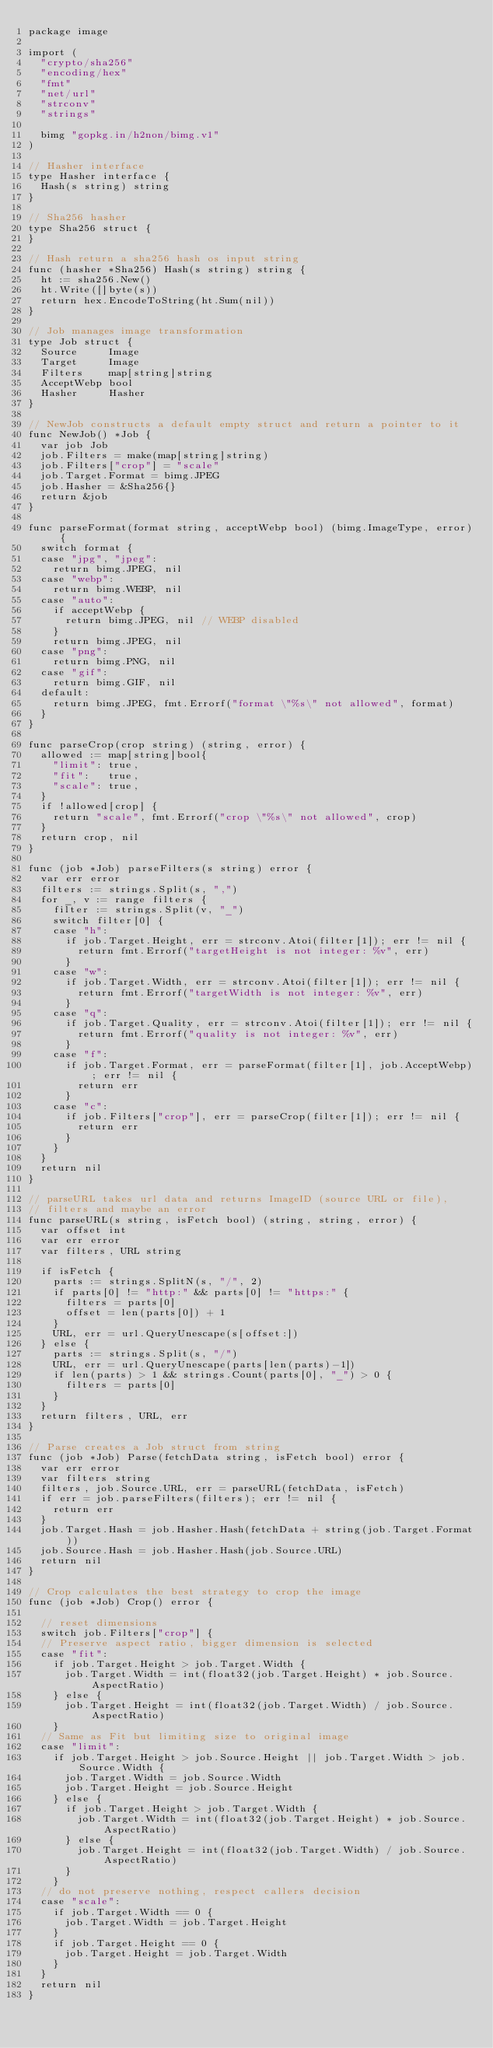<code> <loc_0><loc_0><loc_500><loc_500><_Go_>package image

import (
	"crypto/sha256"
	"encoding/hex"
	"fmt"
	"net/url"
	"strconv"
	"strings"

	bimg "gopkg.in/h2non/bimg.v1"
)

// Hasher interface
type Hasher interface {
	Hash(s string) string
}

// Sha256 hasher
type Sha256 struct {
}

// Hash return a sha256 hash os input string
func (hasher *Sha256) Hash(s string) string {
	ht := sha256.New()
	ht.Write([]byte(s))
	return hex.EncodeToString(ht.Sum(nil))
}

// Job manages image transformation
type Job struct {
	Source     Image
	Target     Image
	Filters    map[string]string
	AcceptWebp bool
	Hasher     Hasher
}

// NewJob constructs a default empty struct and return a pointer to it
func NewJob() *Job {
	var job Job
	job.Filters = make(map[string]string)
	job.Filters["crop"] = "scale"
	job.Target.Format = bimg.JPEG
	job.Hasher = &Sha256{}
	return &job
}

func parseFormat(format string, acceptWebp bool) (bimg.ImageType, error) {
	switch format {
	case "jpg", "jpeg":
		return bimg.JPEG, nil
	case "webp":
		return bimg.WEBP, nil
	case "auto":
		if acceptWebp {
			return bimg.JPEG, nil // WEBP disabled
		}
		return bimg.JPEG, nil
	case "png":
		return bimg.PNG, nil
	case "gif":
		return bimg.GIF, nil
	default:
		return bimg.JPEG, fmt.Errorf("format \"%s\" not allowed", format)
	}
}

func parseCrop(crop string) (string, error) {
	allowed := map[string]bool{
		"limit": true,
		"fit":   true,
		"scale": true,
	}
	if !allowed[crop] {
		return "scale", fmt.Errorf("crop \"%s\" not allowed", crop)
	}
	return crop, nil
}

func (job *Job) parseFilters(s string) error {
	var err error
	filters := strings.Split(s, ",")
	for _, v := range filters {
		filter := strings.Split(v, "_")
		switch filter[0] {
		case "h":
			if job.Target.Height, err = strconv.Atoi(filter[1]); err != nil {
				return fmt.Errorf("targetHeight is not integer: %v", err)
			}
		case "w":
			if job.Target.Width, err = strconv.Atoi(filter[1]); err != nil {
				return fmt.Errorf("targetWidth is not integer: %v", err)
			}
		case "q":
			if job.Target.Quality, err = strconv.Atoi(filter[1]); err != nil {
				return fmt.Errorf("quality is not integer: %v", err)
			}
		case "f":
			if job.Target.Format, err = parseFormat(filter[1], job.AcceptWebp); err != nil {
				return err
			}
		case "c":
			if job.Filters["crop"], err = parseCrop(filter[1]); err != nil {
				return err
			}
		}
	}
	return nil
}

// parseURL takes url data and returns ImageID (source URL or file),
// filters and maybe an error
func parseURL(s string, isFetch bool) (string, string, error) {
	var offset int
	var err error
	var filters, URL string

	if isFetch {
		parts := strings.SplitN(s, "/", 2)
		if parts[0] != "http:" && parts[0] != "https:" {
			filters = parts[0]
			offset = len(parts[0]) + 1
		}
		URL, err = url.QueryUnescape(s[offset:])
	} else {
		parts := strings.Split(s, "/")
		URL, err = url.QueryUnescape(parts[len(parts)-1])
		if len(parts) > 1 && strings.Count(parts[0], "_") > 0 {
			filters = parts[0]
		}
	}
	return filters, URL, err
}

// Parse creates a Job struct from string
func (job *Job) Parse(fetchData string, isFetch bool) error {
	var err error
	var filters string
	filters, job.Source.URL, err = parseURL(fetchData, isFetch)
	if err = job.parseFilters(filters); err != nil {
		return err
	}
	job.Target.Hash = job.Hasher.Hash(fetchData + string(job.Target.Format))
	job.Source.Hash = job.Hasher.Hash(job.Source.URL)
	return nil
}

// Crop calculates the best strategy to crop the image
func (job *Job) Crop() error {

	// reset dimensions
	switch job.Filters["crop"] {
	// Preserve aspect ratio, bigger dimension is selected
	case "fit":
		if job.Target.Height > job.Target.Width {
			job.Target.Width = int(float32(job.Target.Height) * job.Source.AspectRatio)
		} else {
			job.Target.Height = int(float32(job.Target.Width) / job.Source.AspectRatio)
		}
	// Same as Fit but limiting size to original image
	case "limit":
		if job.Target.Height > job.Source.Height || job.Target.Width > job.Source.Width {
			job.Target.Width = job.Source.Width
			job.Target.Height = job.Source.Height
		} else {
			if job.Target.Height > job.Target.Width {
				job.Target.Width = int(float32(job.Target.Height) * job.Source.AspectRatio)
			} else {
				job.Target.Height = int(float32(job.Target.Width) / job.Source.AspectRatio)
			}
		}
	// do not preserve nothing, respect callers decision
	case "scale":
		if job.Target.Width == 0 {
			job.Target.Width = job.Target.Height
		}
		if job.Target.Height == 0 {
			job.Target.Height = job.Target.Width
		}
	}
	return nil
}
</code> 